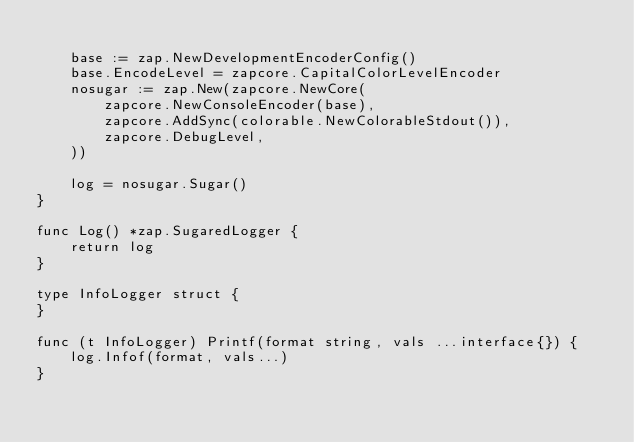<code> <loc_0><loc_0><loc_500><loc_500><_Go_>
	base := zap.NewDevelopmentEncoderConfig()
	base.EncodeLevel = zapcore.CapitalColorLevelEncoder
	nosugar := zap.New(zapcore.NewCore(
		zapcore.NewConsoleEncoder(base),
		zapcore.AddSync(colorable.NewColorableStdout()),
		zapcore.DebugLevel,
	))

	log = nosugar.Sugar()
}

func Log() *zap.SugaredLogger {
	return log
}

type InfoLogger struct {
}

func (t InfoLogger) Printf(format string, vals ...interface{}) {
	log.Infof(format, vals...)
}
</code> 